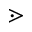<formula> <loc_0><loc_0><loc_500><loc_500>\gtrdot</formula> 